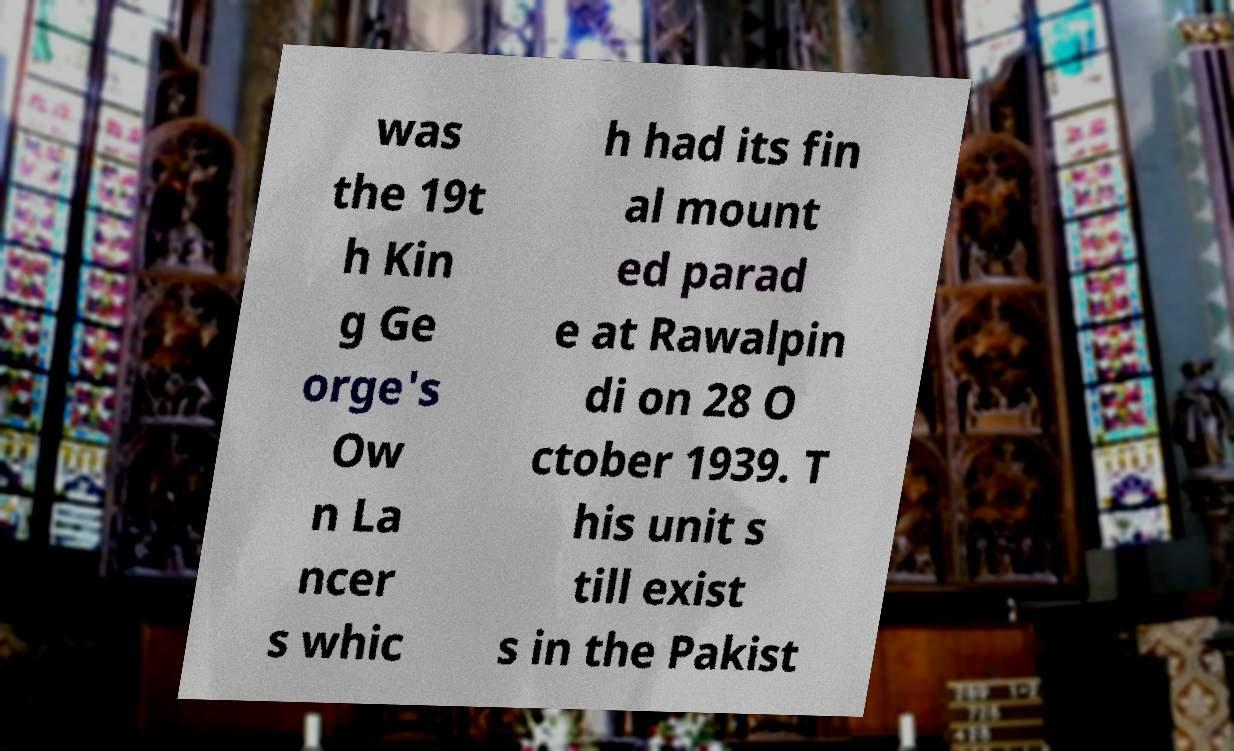Can you accurately transcribe the text from the provided image for me? was the 19t h Kin g Ge orge's Ow n La ncer s whic h had its fin al mount ed parad e at Rawalpin di on 28 O ctober 1939. T his unit s till exist s in the Pakist 